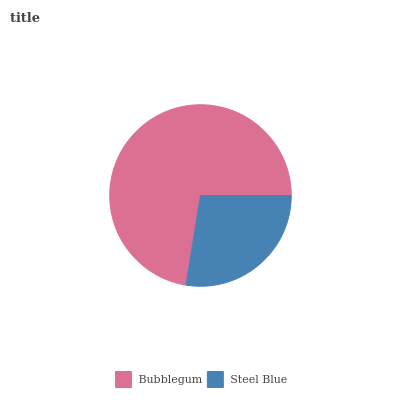Is Steel Blue the minimum?
Answer yes or no. Yes. Is Bubblegum the maximum?
Answer yes or no. Yes. Is Steel Blue the maximum?
Answer yes or no. No. Is Bubblegum greater than Steel Blue?
Answer yes or no. Yes. Is Steel Blue less than Bubblegum?
Answer yes or no. Yes. Is Steel Blue greater than Bubblegum?
Answer yes or no. No. Is Bubblegum less than Steel Blue?
Answer yes or no. No. Is Bubblegum the high median?
Answer yes or no. Yes. Is Steel Blue the low median?
Answer yes or no. Yes. Is Steel Blue the high median?
Answer yes or no. No. Is Bubblegum the low median?
Answer yes or no. No. 